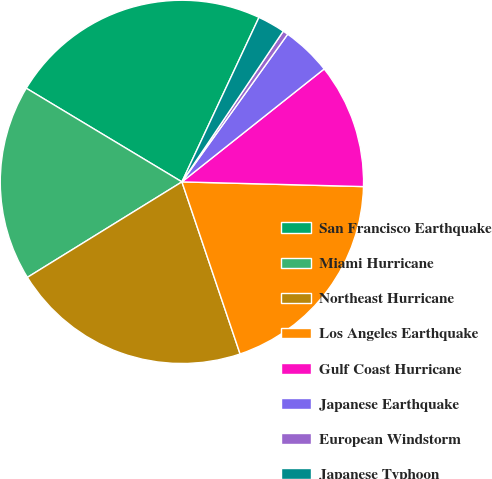<chart> <loc_0><loc_0><loc_500><loc_500><pie_chart><fcel>San Francisco Earthquake<fcel>Miami Hurricane<fcel>Northeast Hurricane<fcel>Los Angeles Earthquake<fcel>Gulf Coast Hurricane<fcel>Japanese Earthquake<fcel>European Windstorm<fcel>Japanese Typhoon<nl><fcel>23.35%<fcel>17.43%<fcel>21.38%<fcel>19.4%<fcel>11.09%<fcel>4.43%<fcel>0.47%<fcel>2.45%<nl></chart> 